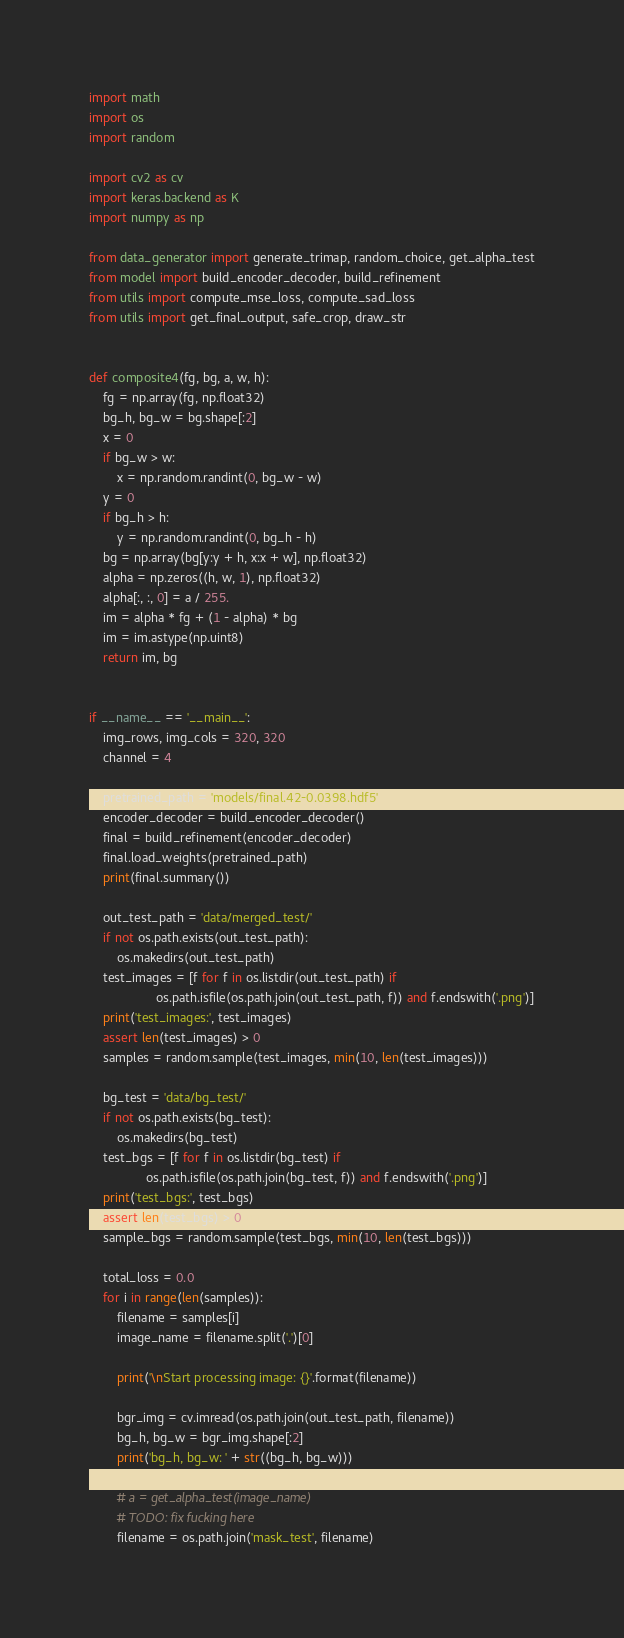<code> <loc_0><loc_0><loc_500><loc_500><_Python_>import math
import os
import random

import cv2 as cv
import keras.backend as K
import numpy as np

from data_generator import generate_trimap, random_choice, get_alpha_test
from model import build_encoder_decoder, build_refinement
from utils import compute_mse_loss, compute_sad_loss
from utils import get_final_output, safe_crop, draw_str


def composite4(fg, bg, a, w, h):
    fg = np.array(fg, np.float32)
    bg_h, bg_w = bg.shape[:2]
    x = 0
    if bg_w > w:
        x = np.random.randint(0, bg_w - w)
    y = 0
    if bg_h > h:
        y = np.random.randint(0, bg_h - h)
    bg = np.array(bg[y:y + h, x:x + w], np.float32)
    alpha = np.zeros((h, w, 1), np.float32)
    alpha[:, :, 0] = a / 255.
    im = alpha * fg + (1 - alpha) * bg
    im = im.astype(np.uint8)
    return im, bg


if __name__ == '__main__':
    img_rows, img_cols = 320, 320
    channel = 4

    pretrained_path = 'models/final.42-0.0398.hdf5'
    encoder_decoder = build_encoder_decoder()
    final = build_refinement(encoder_decoder)
    final.load_weights(pretrained_path)
    print(final.summary())

    out_test_path = 'data/merged_test/'
    if not os.path.exists(out_test_path):
        os.makedirs(out_test_path)
    test_images = [f for f in os.listdir(out_test_path) if
                   os.path.isfile(os.path.join(out_test_path, f)) and f.endswith('.png')]
    print('test_images:', test_images)
    assert len(test_images) > 0
    samples = random.sample(test_images, min(10, len(test_images)))

    bg_test = 'data/bg_test/'
    if not os.path.exists(bg_test):
        os.makedirs(bg_test)
    test_bgs = [f for f in os.listdir(bg_test) if
                os.path.isfile(os.path.join(bg_test, f)) and f.endswith('.png')]
    print('test_bgs:', test_bgs)
    assert len(test_bgs) > 0
    sample_bgs = random.sample(test_bgs, min(10, len(test_bgs)))

    total_loss = 0.0
    for i in range(len(samples)):
        filename = samples[i]
        image_name = filename.split('.')[0]

        print('\nStart processing image: {}'.format(filename))

        bgr_img = cv.imread(os.path.join(out_test_path, filename))
        bg_h, bg_w = bgr_img.shape[:2]
        print('bg_h, bg_w: ' + str((bg_h, bg_w)))

        # a = get_alpha_test(image_name)
        # TODO: fix fucking here
        filename = os.path.join('mask_test', filename)</code> 